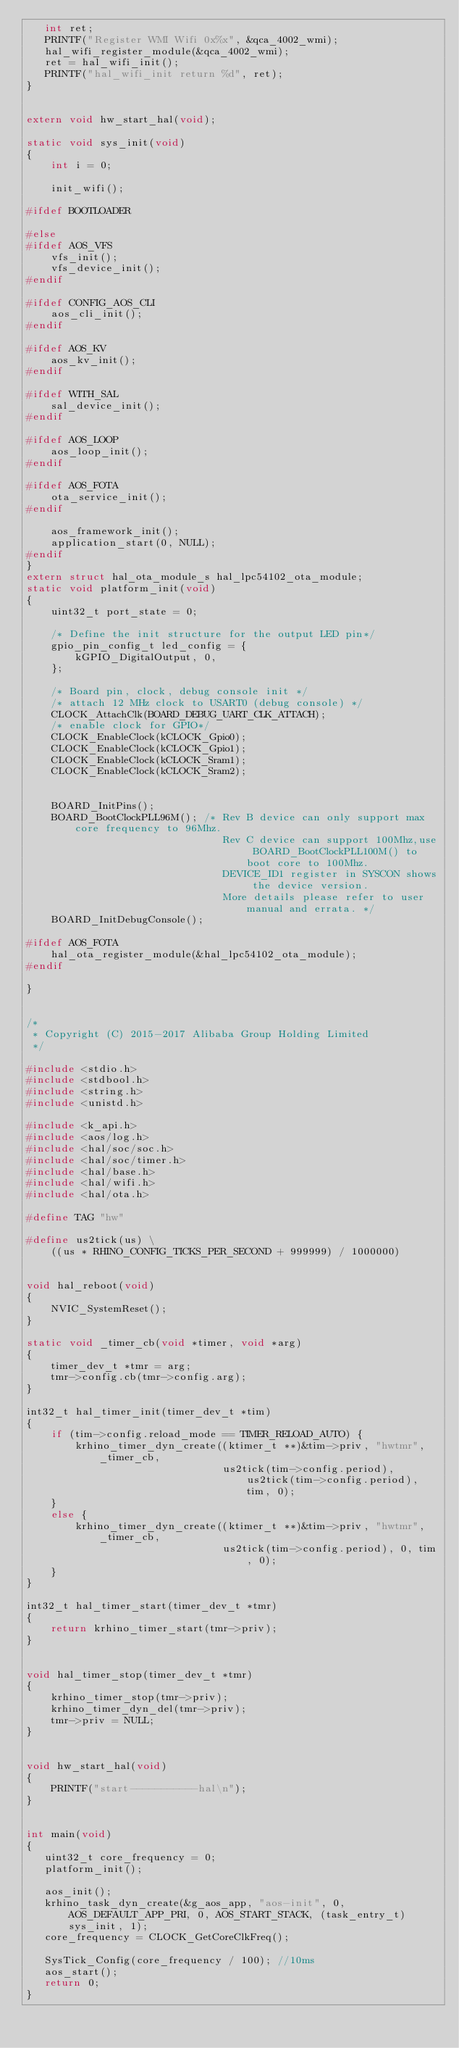Convert code to text. <code><loc_0><loc_0><loc_500><loc_500><_C_>   int ret;
   PRINTF("Register WMI Wifi 0x%x", &qca_4002_wmi);
   hal_wifi_register_module(&qca_4002_wmi);
   ret = hal_wifi_init();
   PRINTF("hal_wifi_init return %d", ret);
}


extern void hw_start_hal(void);

static void sys_init(void)
{
    int i = 0;

    init_wifi();

#ifdef BOOTLOADER

#else
#ifdef AOS_VFS
    vfs_init();
    vfs_device_init();
#endif

#ifdef CONFIG_AOS_CLI
    aos_cli_init();
#endif

#ifdef AOS_KV
    aos_kv_init();
#endif

#ifdef WITH_SAL
    sal_device_init();
#endif

#ifdef AOS_LOOP
    aos_loop_init();
#endif

#ifdef AOS_FOTA 
    ota_service_init();
#endif

    aos_framework_init();
    application_start(0, NULL);	
#endif
}
extern struct hal_ota_module_s hal_lpc54102_ota_module;
static void platform_init(void)
{
    uint32_t port_state = 0;

    /* Define the init structure for the output LED pin*/
    gpio_pin_config_t led_config = {
        kGPIO_DigitalOutput, 0,
    };

    /* Board pin, clock, debug console init */
    /* attach 12 MHz clock to USART0 (debug console) */
    CLOCK_AttachClk(BOARD_DEBUG_UART_CLK_ATTACH);
    /* enable clock for GPIO*/
    CLOCK_EnableClock(kCLOCK_Gpio0);
    CLOCK_EnableClock(kCLOCK_Gpio1);
    CLOCK_EnableClock(kCLOCK_Sram1);
    CLOCK_EnableClock(kCLOCK_Sram2);


    BOARD_InitPins();
    BOARD_BootClockPLL96M(); /* Rev B device can only support max core frequency to 96Mhz.
                                Rev C device can support 100Mhz,use BOARD_BootClockPLL100M() to boot core to 100Mhz. 
                                DEVICE_ID1 register in SYSCON shows the device version.
                                More details please refer to user manual and errata. */
    BOARD_InitDebugConsole();	

#ifdef AOS_FOTA
    hal_ota_register_module(&hal_lpc54102_ota_module);
#endif

}


/*
 * Copyright (C) 2015-2017 Alibaba Group Holding Limited
 */

#include <stdio.h>
#include <stdbool.h>
#include <string.h>
#include <unistd.h>

#include <k_api.h>
#include <aos/log.h>
#include <hal/soc/soc.h>
#include <hal/soc/timer.h>
#include <hal/base.h>
#include <hal/wifi.h>
#include <hal/ota.h>

#define TAG "hw"

#define us2tick(us) \
    ((us * RHINO_CONFIG_TICKS_PER_SECOND + 999999) / 1000000)


void hal_reboot(void)
{
    NVIC_SystemReset();
}

static void _timer_cb(void *timer, void *arg)
{
    timer_dev_t *tmr = arg;
    tmr->config.cb(tmr->config.arg);
}

int32_t hal_timer_init(timer_dev_t *tim)
{
    if (tim->config.reload_mode == TIMER_RELOAD_AUTO) {
        krhino_timer_dyn_create((ktimer_t **)&tim->priv, "hwtmr", _timer_cb,
                                us2tick(tim->config.period), us2tick(tim->config.period), tim, 0);
    }
    else {
        krhino_timer_dyn_create((ktimer_t **)&tim->priv, "hwtmr", _timer_cb,
                                us2tick(tim->config.period), 0, tim, 0);
    }
}

int32_t hal_timer_start(timer_dev_t *tmr)
{
    return krhino_timer_start(tmr->priv);
}


void hal_timer_stop(timer_dev_t *tmr)
{
    krhino_timer_stop(tmr->priv);
    krhino_timer_dyn_del(tmr->priv);
    tmr->priv = NULL;
}


void hw_start_hal(void)
{
    PRINTF("start-----------hal\n");
}


int main(void)
{
   uint32_t core_frequency = 0;
   platform_init();
	
   aos_init();
   krhino_task_dyn_create(&g_aos_app, "aos-init", 0, AOS_DEFAULT_APP_PRI, 0, AOS_START_STACK, (task_entry_t)sys_init, 1);
   core_frequency = CLOCK_GetCoreClkFreq();

   SysTick_Config(core_frequency / 100); //10ms
   aos_start();
   return 0;
}


</code> 